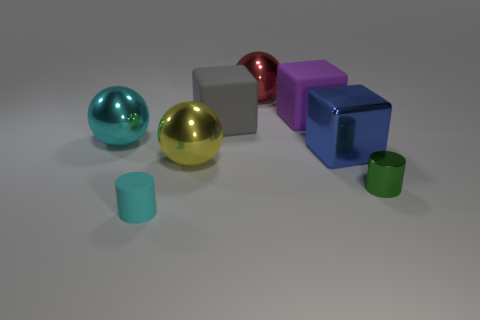Does the blue cube have the same material as the purple object?
Your response must be concise. No. The large metallic ball that is on the left side of the cyan thing that is in front of the thing that is on the left side of the tiny cyan cylinder is what color?
Offer a terse response. Cyan. There is a gray object; what shape is it?
Your answer should be very brief. Cube. There is a tiny rubber cylinder; does it have the same color as the big sphere that is to the left of the yellow thing?
Provide a succinct answer. Yes. Is the number of small green metallic objects left of the purple matte object the same as the number of small brown metallic cylinders?
Offer a terse response. Yes. How many other cyan balls are the same size as the cyan shiny sphere?
Give a very brief answer. 0. The big thing that is the same color as the small matte cylinder is what shape?
Your response must be concise. Sphere. Are there any large cyan metallic cylinders?
Keep it short and to the point. No. Does the matte thing in front of the big blue thing have the same shape as the shiny object that is on the right side of the blue thing?
Make the answer very short. Yes. What number of small things are green cylinders or rubber cubes?
Give a very brief answer. 1. 